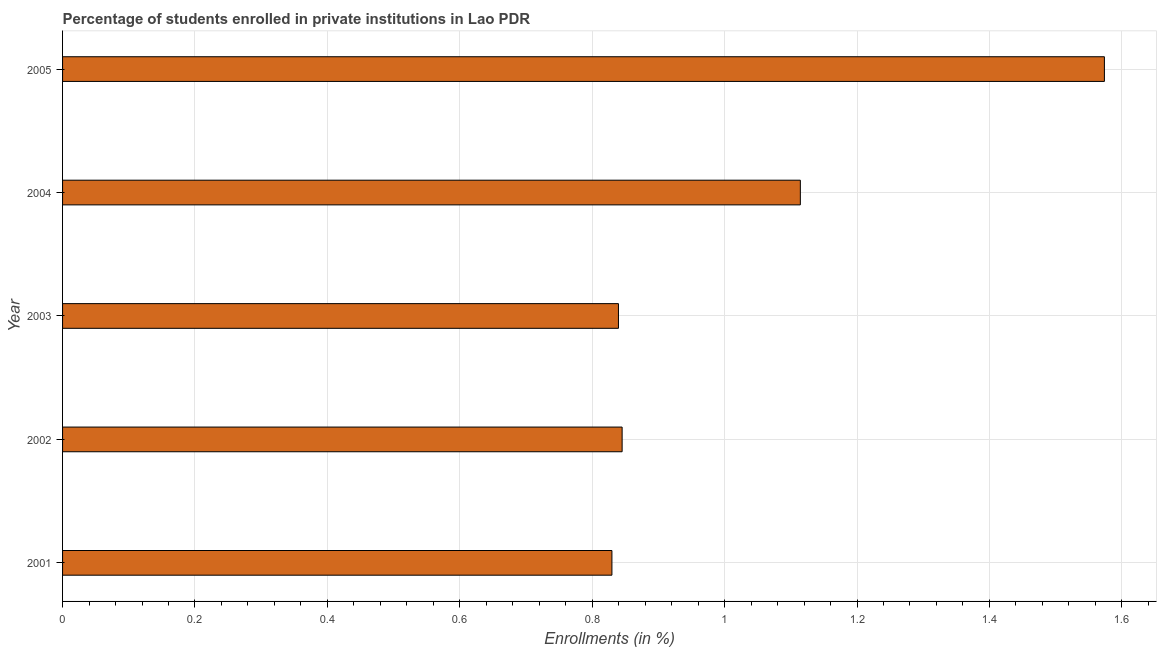Does the graph contain grids?
Provide a succinct answer. Yes. What is the title of the graph?
Keep it short and to the point. Percentage of students enrolled in private institutions in Lao PDR. What is the label or title of the X-axis?
Make the answer very short. Enrollments (in %). What is the label or title of the Y-axis?
Give a very brief answer. Year. What is the enrollments in private institutions in 2001?
Your answer should be very brief. 0.83. Across all years, what is the maximum enrollments in private institutions?
Your answer should be very brief. 1.57. Across all years, what is the minimum enrollments in private institutions?
Give a very brief answer. 0.83. What is the sum of the enrollments in private institutions?
Make the answer very short. 5.2. What is the difference between the enrollments in private institutions in 2003 and 2004?
Make the answer very short. -0.28. What is the average enrollments in private institutions per year?
Your answer should be very brief. 1.04. What is the median enrollments in private institutions?
Ensure brevity in your answer.  0.85. In how many years, is the enrollments in private institutions greater than 1.04 %?
Offer a terse response. 2. Do a majority of the years between 2001 and 2004 (inclusive) have enrollments in private institutions greater than 1.56 %?
Your answer should be very brief. No. What is the ratio of the enrollments in private institutions in 2003 to that in 2005?
Make the answer very short. 0.53. Is the enrollments in private institutions in 2001 less than that in 2004?
Make the answer very short. Yes. Is the difference between the enrollments in private institutions in 2002 and 2003 greater than the difference between any two years?
Give a very brief answer. No. What is the difference between the highest and the second highest enrollments in private institutions?
Provide a succinct answer. 0.46. What is the difference between the highest and the lowest enrollments in private institutions?
Offer a terse response. 0.74. In how many years, is the enrollments in private institutions greater than the average enrollments in private institutions taken over all years?
Your answer should be compact. 2. How many bars are there?
Offer a very short reply. 5. Are all the bars in the graph horizontal?
Offer a terse response. Yes. How many years are there in the graph?
Make the answer very short. 5. What is the Enrollments (in %) in 2001?
Your answer should be compact. 0.83. What is the Enrollments (in %) of 2002?
Give a very brief answer. 0.85. What is the Enrollments (in %) of 2003?
Your response must be concise. 0.84. What is the Enrollments (in %) of 2004?
Offer a very short reply. 1.11. What is the Enrollments (in %) in 2005?
Ensure brevity in your answer.  1.57. What is the difference between the Enrollments (in %) in 2001 and 2002?
Your answer should be compact. -0.02. What is the difference between the Enrollments (in %) in 2001 and 2003?
Keep it short and to the point. -0.01. What is the difference between the Enrollments (in %) in 2001 and 2004?
Offer a terse response. -0.28. What is the difference between the Enrollments (in %) in 2001 and 2005?
Offer a very short reply. -0.74. What is the difference between the Enrollments (in %) in 2002 and 2003?
Ensure brevity in your answer.  0.01. What is the difference between the Enrollments (in %) in 2002 and 2004?
Keep it short and to the point. -0.27. What is the difference between the Enrollments (in %) in 2002 and 2005?
Your answer should be compact. -0.73. What is the difference between the Enrollments (in %) in 2003 and 2004?
Your answer should be very brief. -0.27. What is the difference between the Enrollments (in %) in 2003 and 2005?
Make the answer very short. -0.73. What is the difference between the Enrollments (in %) in 2004 and 2005?
Your answer should be compact. -0.46. What is the ratio of the Enrollments (in %) in 2001 to that in 2002?
Provide a succinct answer. 0.98. What is the ratio of the Enrollments (in %) in 2001 to that in 2004?
Keep it short and to the point. 0.74. What is the ratio of the Enrollments (in %) in 2001 to that in 2005?
Give a very brief answer. 0.53. What is the ratio of the Enrollments (in %) in 2002 to that in 2004?
Provide a succinct answer. 0.76. What is the ratio of the Enrollments (in %) in 2002 to that in 2005?
Your response must be concise. 0.54. What is the ratio of the Enrollments (in %) in 2003 to that in 2004?
Keep it short and to the point. 0.75. What is the ratio of the Enrollments (in %) in 2003 to that in 2005?
Give a very brief answer. 0.53. What is the ratio of the Enrollments (in %) in 2004 to that in 2005?
Your response must be concise. 0.71. 